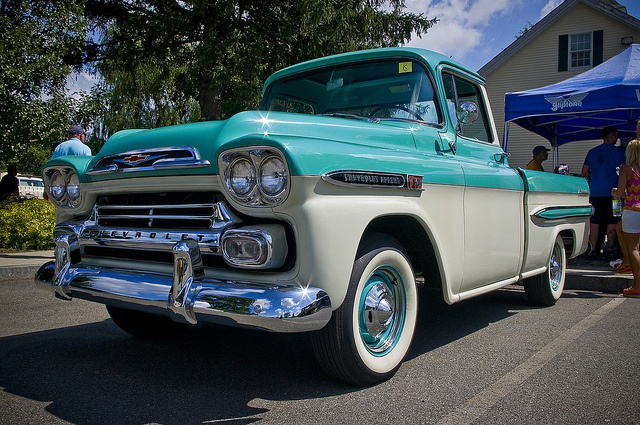Describe the objects in this image and their specific colors. I can see truck in blue, black, gray, darkgray, and teal tones, people in blue, black, navy, gray, and teal tones, people in blue, black, maroon, gray, and olive tones, people in blue, lightblue, teal, and black tones, and people in blue, black, maroon, darkgreen, and purple tones in this image. 